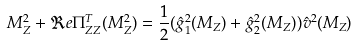<formula> <loc_0><loc_0><loc_500><loc_500>M _ { Z } ^ { 2 } + \Re e \Pi _ { Z Z } ^ { T } ( M _ { Z } ^ { 2 } ) = \frac { 1 } { 2 } ( \hat { g } _ { 1 } ^ { 2 } ( M _ { Z } ) + \hat { g } _ { 2 } ^ { 2 } ( M _ { Z } ) ) \hat { v } ^ { 2 } ( M _ { Z } )</formula> 